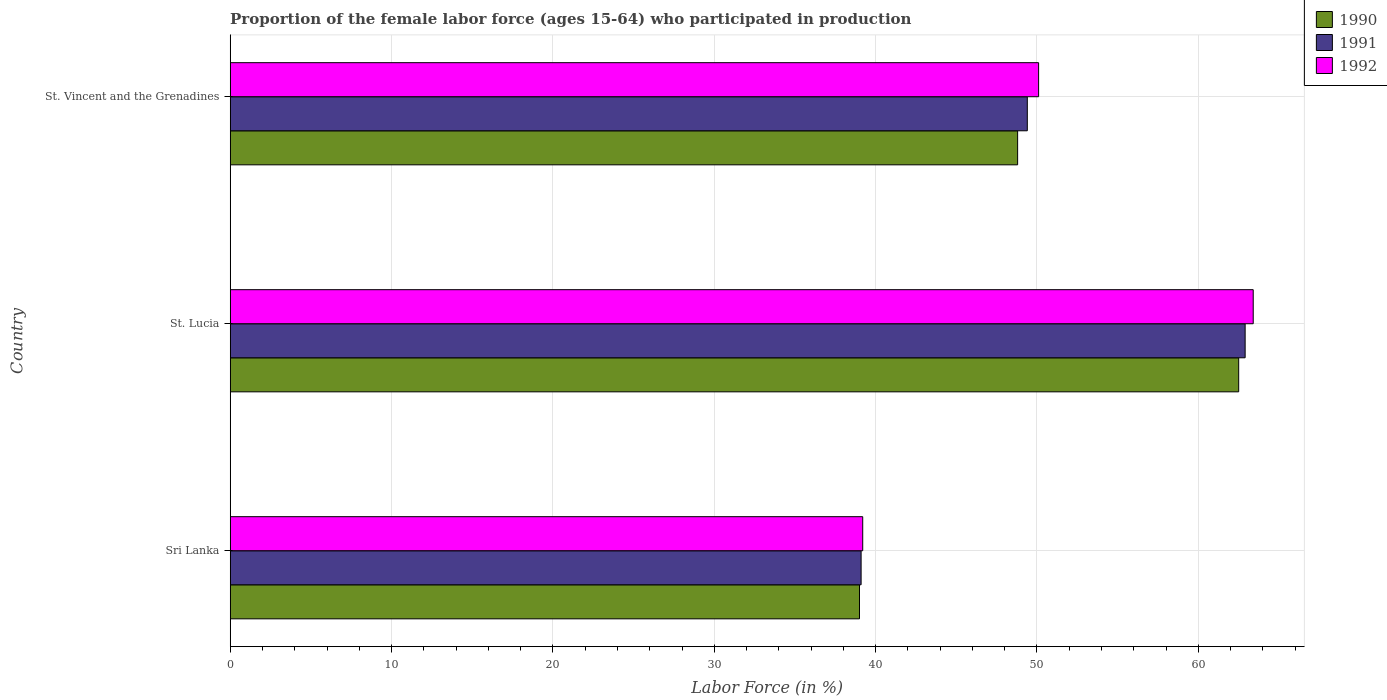How many different coloured bars are there?
Make the answer very short. 3. How many groups of bars are there?
Make the answer very short. 3. Are the number of bars per tick equal to the number of legend labels?
Give a very brief answer. Yes. How many bars are there on the 2nd tick from the top?
Give a very brief answer. 3. How many bars are there on the 1st tick from the bottom?
Your answer should be compact. 3. What is the label of the 1st group of bars from the top?
Provide a succinct answer. St. Vincent and the Grenadines. What is the proportion of the female labor force who participated in production in 1991 in St. Lucia?
Provide a short and direct response. 62.9. Across all countries, what is the maximum proportion of the female labor force who participated in production in 1991?
Your answer should be compact. 62.9. Across all countries, what is the minimum proportion of the female labor force who participated in production in 1991?
Keep it short and to the point. 39.1. In which country was the proportion of the female labor force who participated in production in 1991 maximum?
Offer a terse response. St. Lucia. In which country was the proportion of the female labor force who participated in production in 1990 minimum?
Your answer should be very brief. Sri Lanka. What is the total proportion of the female labor force who participated in production in 1991 in the graph?
Keep it short and to the point. 151.4. What is the difference between the proportion of the female labor force who participated in production in 1991 in Sri Lanka and that in St. Vincent and the Grenadines?
Provide a short and direct response. -10.3. What is the difference between the proportion of the female labor force who participated in production in 1991 in Sri Lanka and the proportion of the female labor force who participated in production in 1990 in St. Vincent and the Grenadines?
Provide a short and direct response. -9.7. What is the average proportion of the female labor force who participated in production in 1990 per country?
Provide a short and direct response. 50.1. In how many countries, is the proportion of the female labor force who participated in production in 1990 greater than 52 %?
Your answer should be compact. 1. What is the ratio of the proportion of the female labor force who participated in production in 1992 in Sri Lanka to that in St. Vincent and the Grenadines?
Provide a short and direct response. 0.78. Is the proportion of the female labor force who participated in production in 1991 in Sri Lanka less than that in St. Lucia?
Your response must be concise. Yes. Is the difference between the proportion of the female labor force who participated in production in 1991 in Sri Lanka and St. Lucia greater than the difference between the proportion of the female labor force who participated in production in 1992 in Sri Lanka and St. Lucia?
Ensure brevity in your answer.  Yes. What is the difference between the highest and the second highest proportion of the female labor force who participated in production in 1991?
Your answer should be compact. 13.5. What is the difference between the highest and the lowest proportion of the female labor force who participated in production in 1990?
Your answer should be compact. 23.5. In how many countries, is the proportion of the female labor force who participated in production in 1991 greater than the average proportion of the female labor force who participated in production in 1991 taken over all countries?
Provide a short and direct response. 1. What does the 2nd bar from the top in Sri Lanka represents?
Make the answer very short. 1991. What does the 1st bar from the bottom in St. Vincent and the Grenadines represents?
Provide a succinct answer. 1990. How many bars are there?
Offer a very short reply. 9. What is the difference between two consecutive major ticks on the X-axis?
Offer a terse response. 10. Are the values on the major ticks of X-axis written in scientific E-notation?
Make the answer very short. No. Where does the legend appear in the graph?
Ensure brevity in your answer.  Top right. How are the legend labels stacked?
Offer a very short reply. Vertical. What is the title of the graph?
Your answer should be compact. Proportion of the female labor force (ages 15-64) who participated in production. What is the label or title of the X-axis?
Your answer should be compact. Labor Force (in %). What is the Labor Force (in %) of 1991 in Sri Lanka?
Ensure brevity in your answer.  39.1. What is the Labor Force (in %) in 1992 in Sri Lanka?
Offer a terse response. 39.2. What is the Labor Force (in %) of 1990 in St. Lucia?
Give a very brief answer. 62.5. What is the Labor Force (in %) of 1991 in St. Lucia?
Provide a succinct answer. 62.9. What is the Labor Force (in %) of 1992 in St. Lucia?
Give a very brief answer. 63.4. What is the Labor Force (in %) in 1990 in St. Vincent and the Grenadines?
Offer a very short reply. 48.8. What is the Labor Force (in %) in 1991 in St. Vincent and the Grenadines?
Keep it short and to the point. 49.4. What is the Labor Force (in %) of 1992 in St. Vincent and the Grenadines?
Give a very brief answer. 50.1. Across all countries, what is the maximum Labor Force (in %) of 1990?
Provide a short and direct response. 62.5. Across all countries, what is the maximum Labor Force (in %) in 1991?
Give a very brief answer. 62.9. Across all countries, what is the maximum Labor Force (in %) of 1992?
Give a very brief answer. 63.4. Across all countries, what is the minimum Labor Force (in %) in 1991?
Your answer should be compact. 39.1. Across all countries, what is the minimum Labor Force (in %) in 1992?
Provide a succinct answer. 39.2. What is the total Labor Force (in %) in 1990 in the graph?
Give a very brief answer. 150.3. What is the total Labor Force (in %) of 1991 in the graph?
Make the answer very short. 151.4. What is the total Labor Force (in %) of 1992 in the graph?
Ensure brevity in your answer.  152.7. What is the difference between the Labor Force (in %) in 1990 in Sri Lanka and that in St. Lucia?
Offer a terse response. -23.5. What is the difference between the Labor Force (in %) in 1991 in Sri Lanka and that in St. Lucia?
Offer a very short reply. -23.8. What is the difference between the Labor Force (in %) in 1992 in Sri Lanka and that in St. Lucia?
Your response must be concise. -24.2. What is the difference between the Labor Force (in %) of 1991 in St. Lucia and that in St. Vincent and the Grenadines?
Your answer should be very brief. 13.5. What is the difference between the Labor Force (in %) of 1990 in Sri Lanka and the Labor Force (in %) of 1991 in St. Lucia?
Provide a short and direct response. -23.9. What is the difference between the Labor Force (in %) in 1990 in Sri Lanka and the Labor Force (in %) in 1992 in St. Lucia?
Offer a terse response. -24.4. What is the difference between the Labor Force (in %) in 1991 in Sri Lanka and the Labor Force (in %) in 1992 in St. Lucia?
Your answer should be compact. -24.3. What is the difference between the Labor Force (in %) in 1990 in Sri Lanka and the Labor Force (in %) in 1991 in St. Vincent and the Grenadines?
Offer a very short reply. -10.4. What is the difference between the Labor Force (in %) of 1990 in Sri Lanka and the Labor Force (in %) of 1992 in St. Vincent and the Grenadines?
Make the answer very short. -11.1. What is the difference between the Labor Force (in %) of 1990 in St. Lucia and the Labor Force (in %) of 1991 in St. Vincent and the Grenadines?
Provide a short and direct response. 13.1. What is the difference between the Labor Force (in %) in 1990 in St. Lucia and the Labor Force (in %) in 1992 in St. Vincent and the Grenadines?
Offer a terse response. 12.4. What is the average Labor Force (in %) of 1990 per country?
Provide a succinct answer. 50.1. What is the average Labor Force (in %) of 1991 per country?
Your answer should be very brief. 50.47. What is the average Labor Force (in %) of 1992 per country?
Give a very brief answer. 50.9. What is the difference between the Labor Force (in %) of 1991 and Labor Force (in %) of 1992 in Sri Lanka?
Provide a short and direct response. -0.1. What is the difference between the Labor Force (in %) of 1990 and Labor Force (in %) of 1992 in St. Lucia?
Your answer should be compact. -0.9. What is the difference between the Labor Force (in %) of 1990 and Labor Force (in %) of 1991 in St. Vincent and the Grenadines?
Give a very brief answer. -0.6. What is the difference between the Labor Force (in %) of 1991 and Labor Force (in %) of 1992 in St. Vincent and the Grenadines?
Ensure brevity in your answer.  -0.7. What is the ratio of the Labor Force (in %) in 1990 in Sri Lanka to that in St. Lucia?
Your answer should be compact. 0.62. What is the ratio of the Labor Force (in %) in 1991 in Sri Lanka to that in St. Lucia?
Provide a short and direct response. 0.62. What is the ratio of the Labor Force (in %) in 1992 in Sri Lanka to that in St. Lucia?
Make the answer very short. 0.62. What is the ratio of the Labor Force (in %) of 1990 in Sri Lanka to that in St. Vincent and the Grenadines?
Your response must be concise. 0.8. What is the ratio of the Labor Force (in %) in 1991 in Sri Lanka to that in St. Vincent and the Grenadines?
Keep it short and to the point. 0.79. What is the ratio of the Labor Force (in %) in 1992 in Sri Lanka to that in St. Vincent and the Grenadines?
Give a very brief answer. 0.78. What is the ratio of the Labor Force (in %) in 1990 in St. Lucia to that in St. Vincent and the Grenadines?
Your response must be concise. 1.28. What is the ratio of the Labor Force (in %) of 1991 in St. Lucia to that in St. Vincent and the Grenadines?
Your answer should be compact. 1.27. What is the ratio of the Labor Force (in %) of 1992 in St. Lucia to that in St. Vincent and the Grenadines?
Ensure brevity in your answer.  1.27. What is the difference between the highest and the second highest Labor Force (in %) of 1990?
Your response must be concise. 13.7. What is the difference between the highest and the lowest Labor Force (in %) of 1991?
Your response must be concise. 23.8. What is the difference between the highest and the lowest Labor Force (in %) in 1992?
Give a very brief answer. 24.2. 